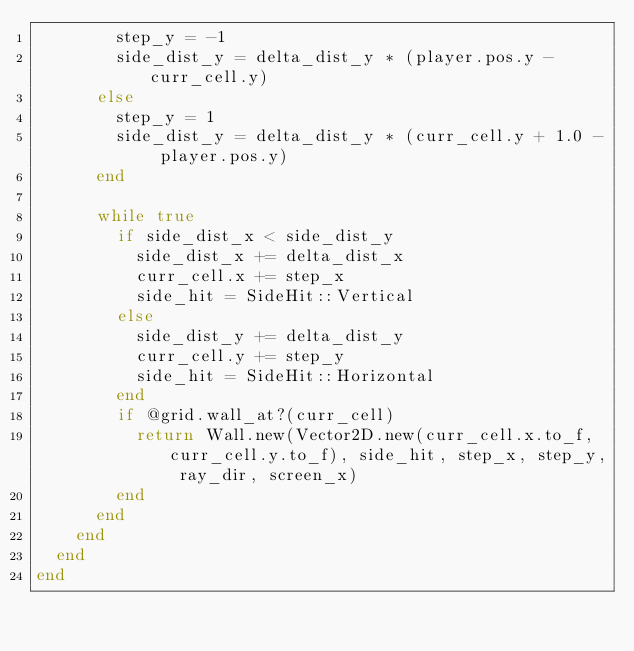<code> <loc_0><loc_0><loc_500><loc_500><_Crystal_>        step_y = -1
        side_dist_y = delta_dist_y * (player.pos.y - curr_cell.y)
      else
        step_y = 1
        side_dist_y = delta_dist_y * (curr_cell.y + 1.0 - player.pos.y)
      end

      while true
        if side_dist_x < side_dist_y
          side_dist_x += delta_dist_x
          curr_cell.x += step_x
          side_hit = SideHit::Vertical
        else
          side_dist_y += delta_dist_y
          curr_cell.y += step_y
          side_hit = SideHit::Horizontal
        end
        if @grid.wall_at?(curr_cell)
          return Wall.new(Vector2D.new(curr_cell.x.to_f, curr_cell.y.to_f), side_hit, step_x, step_y, ray_dir, screen_x)
        end
      end
    end
  end
end
</code> 